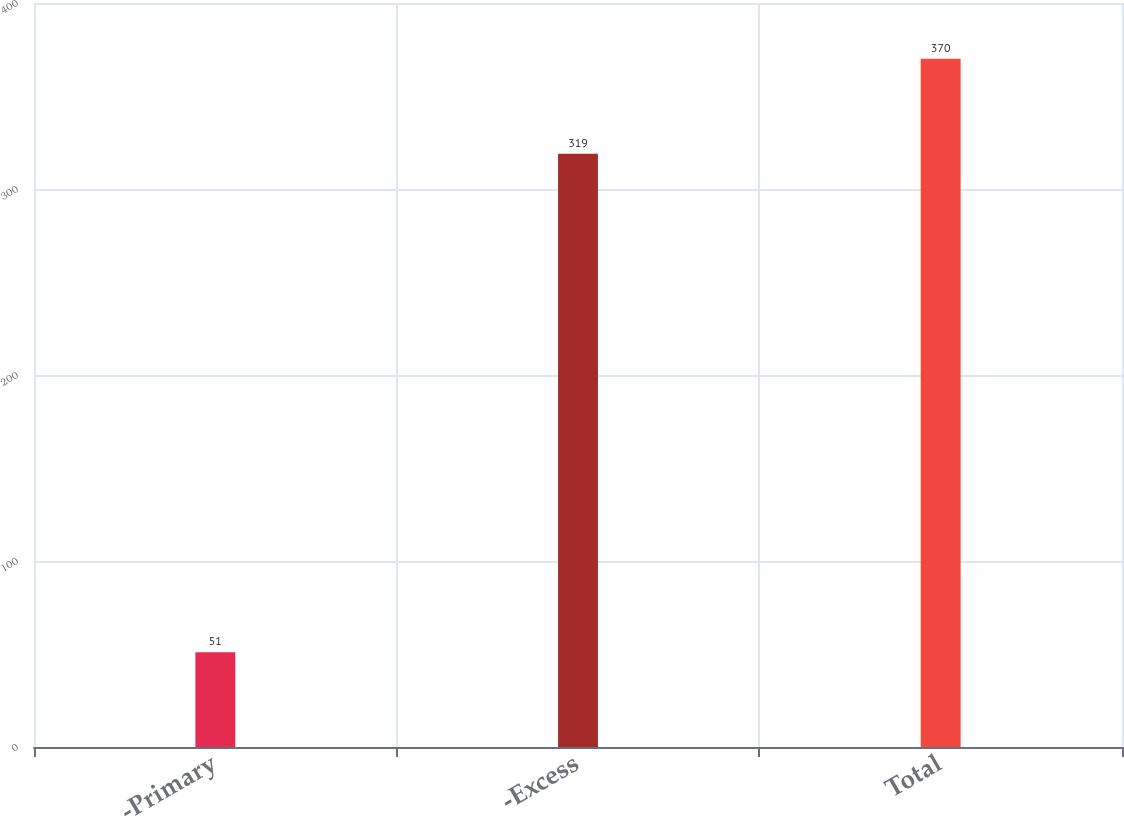Convert chart to OTSL. <chart><loc_0><loc_0><loc_500><loc_500><bar_chart><fcel>-Primary<fcel>-Excess<fcel>Total<nl><fcel>51<fcel>319<fcel>370<nl></chart> 